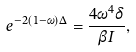Convert formula to latex. <formula><loc_0><loc_0><loc_500><loc_500>e ^ { - 2 ( 1 - \omega ) \Delta } = \frac { 4 \omega ^ { 4 } \delta } { \beta I } ,</formula> 